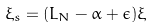Convert formula to latex. <formula><loc_0><loc_0><loc_500><loc_500>\xi _ { s } = ( L _ { N } - \alpha + \epsilon ) \xi</formula> 